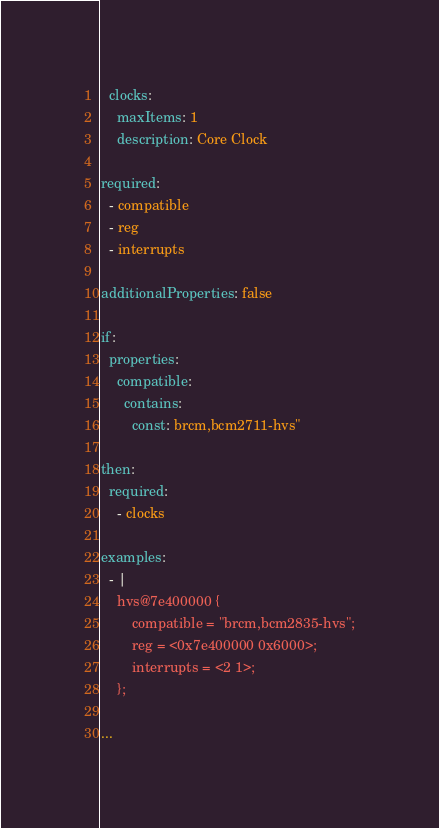Convert code to text. <code><loc_0><loc_0><loc_500><loc_500><_YAML_>  clocks:
    maxItems: 1
    description: Core Clock

required:
  - compatible
  - reg
  - interrupts

additionalProperties: false

if:
  properties:
    compatible:
      contains:
        const: brcm,bcm2711-hvs"

then:
  required:
    - clocks

examples:
  - |
    hvs@7e400000 {
        compatible = "brcm,bcm2835-hvs";
        reg = <0x7e400000 0x6000>;
        interrupts = <2 1>;
    };

...
</code> 